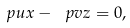Convert formula to latex. <formula><loc_0><loc_0><loc_500><loc_500>\ p { u } { x } - \ p { v } { z } = 0 ,</formula> 